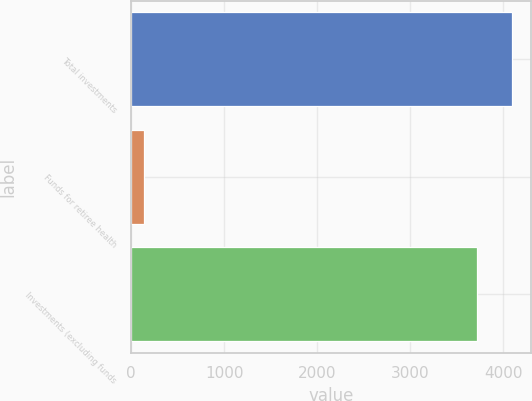Convert chart. <chart><loc_0><loc_0><loc_500><loc_500><bar_chart><fcel>Total investments<fcel>Funds for retiree health<fcel>Investments (excluding funds<nl><fcel>4087.6<fcel>137<fcel>3716<nl></chart> 